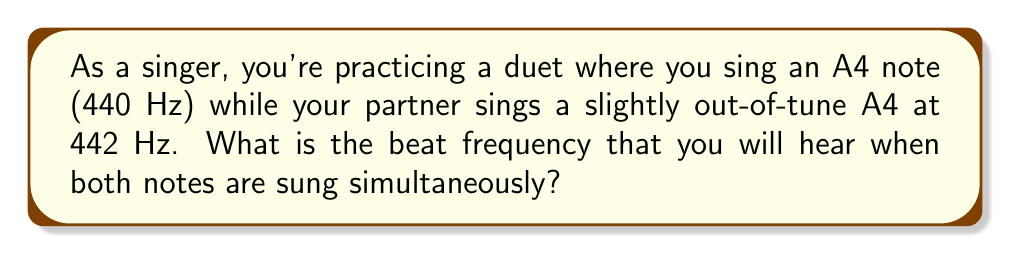Solve this math problem. To solve this problem, we need to understand and apply the concept of beat frequency. When two sound waves with slightly different frequencies are played together, they create a periodic variation in amplitude known as beats. The frequency of these beats is called the beat frequency.

The formula for calculating beat frequency is:

$$f_{\text{beat}} = |f_1 - f_2|$$

Where:
$f_{\text{beat}}$ is the beat frequency
$f_1$ and $f_2$ are the frequencies of the two notes
$| |$ denotes the absolute value

Given:
$f_1 = 440$ Hz (your A4 note)
$f_2 = 442$ Hz (your partner's slightly out-of-tune A4)

Let's calculate:

$$f_{\text{beat}} = |f_1 - f_2|$$
$$f_{\text{beat}} = |440 \text{ Hz} - 442 \text{ Hz}|$$
$$f_{\text{beat}} = |{-2} \text{ Hz}|$$
$$f_{\text{beat}} = 2 \text{ Hz}$$

Therefore, the beat frequency you will hear is 2 Hz, meaning you will hear 2 beats per second when both notes are sung simultaneously.
Answer: 2 Hz 